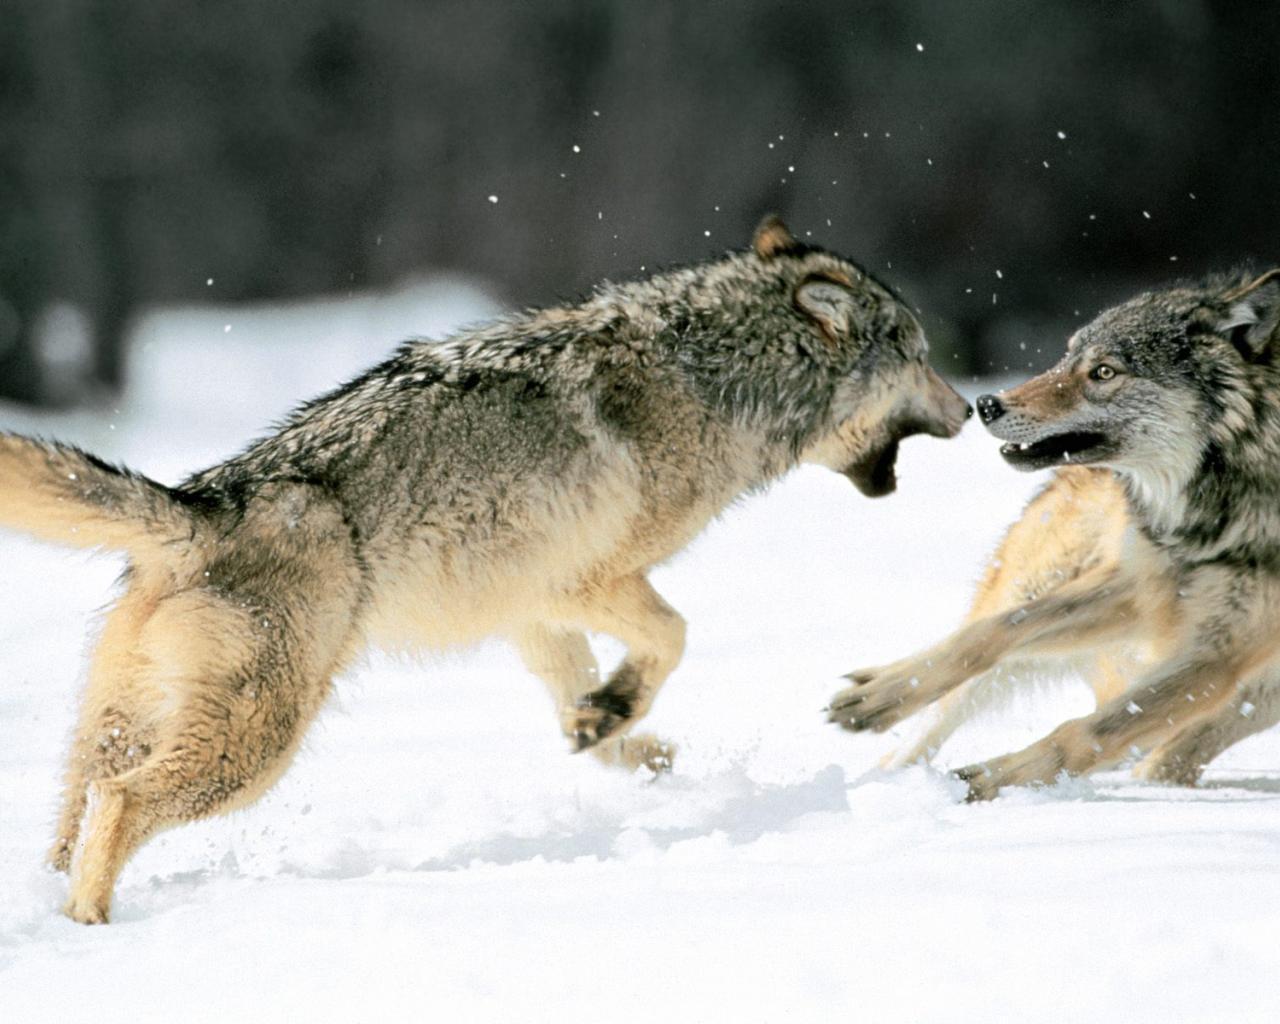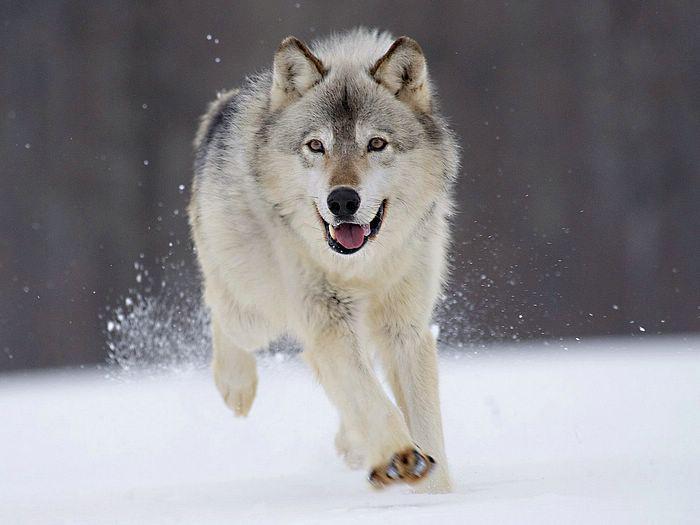The first image is the image on the left, the second image is the image on the right. For the images shown, is this caption "There are at least three wolves standing in the snow." true? Answer yes or no. Yes. 